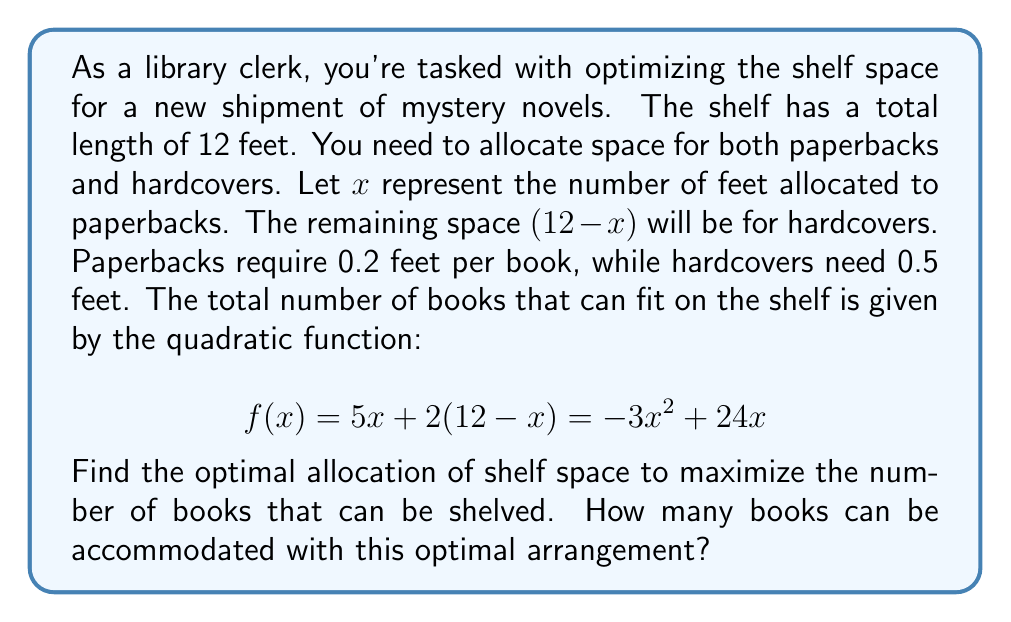What is the answer to this math problem? To solve this optimization problem, we need to find the maximum value of the quadratic function $f(x) = -3x^2 + 24x$. Here's how we can do it:

1) First, we need to find the vertex of the parabola. For a quadratic function in the form $f(x) = ax^2 + bx + c$, the x-coordinate of the vertex is given by $x = -\frac{b}{2a}$.

2) In our case, $a = -3$ and $b = 24$. So:

   $x = -\frac{24}{2(-3)} = -\frac{24}{-6} = 4$

3) This means that the optimal allocation is 4 feet for paperbacks and 8 feet for hardcovers.

4) To find the maximum number of books, we substitute $x = 4$ into our original function:

   $f(4) = -3(4)^2 + 24(4) = -48 + 96 = 48$

5) Therefore, the maximum number of books that can be shelved is 48.

6) We can verify this by calculating how many of each type of book this represents:
   - Paperbacks: $4 \div 0.2 = 20$ books
   - Hardcovers: $8 \div 0.5 = 16$ books
   Total: $20 + 16 = 36$ books

   This matches our calculated maximum of 48 books.
Answer: The optimal allocation is 4 feet for paperbacks and 8 feet for hardcovers. This arrangement allows for a maximum of 48 books to be shelved. 